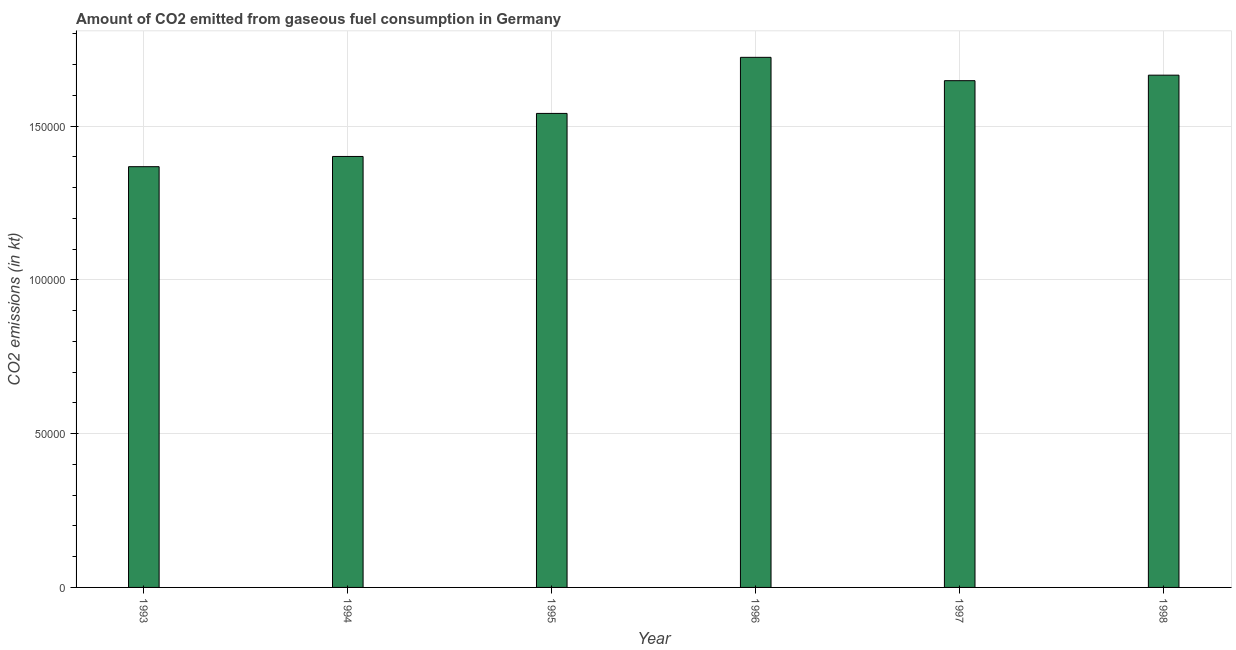What is the title of the graph?
Keep it short and to the point. Amount of CO2 emitted from gaseous fuel consumption in Germany. What is the label or title of the Y-axis?
Offer a very short reply. CO2 emissions (in kt). What is the co2 emissions from gaseous fuel consumption in 1997?
Ensure brevity in your answer.  1.65e+05. Across all years, what is the maximum co2 emissions from gaseous fuel consumption?
Keep it short and to the point. 1.72e+05. Across all years, what is the minimum co2 emissions from gaseous fuel consumption?
Keep it short and to the point. 1.37e+05. In which year was the co2 emissions from gaseous fuel consumption maximum?
Ensure brevity in your answer.  1996. In which year was the co2 emissions from gaseous fuel consumption minimum?
Your answer should be compact. 1993. What is the sum of the co2 emissions from gaseous fuel consumption?
Offer a terse response. 9.35e+05. What is the difference between the co2 emissions from gaseous fuel consumption in 1994 and 1996?
Offer a very short reply. -3.22e+04. What is the average co2 emissions from gaseous fuel consumption per year?
Offer a very short reply. 1.56e+05. What is the median co2 emissions from gaseous fuel consumption?
Offer a terse response. 1.59e+05. In how many years, is the co2 emissions from gaseous fuel consumption greater than 20000 kt?
Your answer should be very brief. 6. Do a majority of the years between 1998 and 1994 (inclusive) have co2 emissions from gaseous fuel consumption greater than 140000 kt?
Your answer should be compact. Yes. What is the ratio of the co2 emissions from gaseous fuel consumption in 1994 to that in 1996?
Make the answer very short. 0.81. What is the difference between the highest and the second highest co2 emissions from gaseous fuel consumption?
Provide a short and direct response. 5801.19. Is the sum of the co2 emissions from gaseous fuel consumption in 1994 and 1995 greater than the maximum co2 emissions from gaseous fuel consumption across all years?
Offer a terse response. Yes. What is the difference between the highest and the lowest co2 emissions from gaseous fuel consumption?
Your answer should be very brief. 3.56e+04. In how many years, is the co2 emissions from gaseous fuel consumption greater than the average co2 emissions from gaseous fuel consumption taken over all years?
Give a very brief answer. 3. How many bars are there?
Provide a succinct answer. 6. Are all the bars in the graph horizontal?
Your answer should be very brief. No. How many years are there in the graph?
Make the answer very short. 6. What is the CO2 emissions (in kt) of 1993?
Your answer should be very brief. 1.37e+05. What is the CO2 emissions (in kt) in 1994?
Offer a very short reply. 1.40e+05. What is the CO2 emissions (in kt) in 1995?
Give a very brief answer. 1.54e+05. What is the CO2 emissions (in kt) in 1996?
Provide a succinct answer. 1.72e+05. What is the CO2 emissions (in kt) in 1997?
Your answer should be compact. 1.65e+05. What is the CO2 emissions (in kt) in 1998?
Ensure brevity in your answer.  1.67e+05. What is the difference between the CO2 emissions (in kt) in 1993 and 1994?
Your answer should be very brief. -3325.97. What is the difference between the CO2 emissions (in kt) in 1993 and 1995?
Provide a short and direct response. -1.73e+04. What is the difference between the CO2 emissions (in kt) in 1993 and 1996?
Your answer should be compact. -3.56e+04. What is the difference between the CO2 emissions (in kt) in 1993 and 1997?
Provide a succinct answer. -2.80e+04. What is the difference between the CO2 emissions (in kt) in 1993 and 1998?
Offer a terse response. -2.98e+04. What is the difference between the CO2 emissions (in kt) in 1994 and 1995?
Your response must be concise. -1.40e+04. What is the difference between the CO2 emissions (in kt) in 1994 and 1996?
Provide a succinct answer. -3.22e+04. What is the difference between the CO2 emissions (in kt) in 1994 and 1997?
Make the answer very short. -2.46e+04. What is the difference between the CO2 emissions (in kt) in 1994 and 1998?
Your answer should be compact. -2.64e+04. What is the difference between the CO2 emissions (in kt) in 1995 and 1996?
Ensure brevity in your answer.  -1.82e+04. What is the difference between the CO2 emissions (in kt) in 1995 and 1997?
Keep it short and to the point. -1.06e+04. What is the difference between the CO2 emissions (in kt) in 1995 and 1998?
Your answer should be compact. -1.24e+04. What is the difference between the CO2 emissions (in kt) in 1996 and 1997?
Offer a terse response. 7590.69. What is the difference between the CO2 emissions (in kt) in 1996 and 1998?
Provide a short and direct response. 5801.19. What is the difference between the CO2 emissions (in kt) in 1997 and 1998?
Provide a short and direct response. -1789.5. What is the ratio of the CO2 emissions (in kt) in 1993 to that in 1994?
Give a very brief answer. 0.98. What is the ratio of the CO2 emissions (in kt) in 1993 to that in 1995?
Provide a short and direct response. 0.89. What is the ratio of the CO2 emissions (in kt) in 1993 to that in 1996?
Keep it short and to the point. 0.79. What is the ratio of the CO2 emissions (in kt) in 1993 to that in 1997?
Your answer should be compact. 0.83. What is the ratio of the CO2 emissions (in kt) in 1993 to that in 1998?
Give a very brief answer. 0.82. What is the ratio of the CO2 emissions (in kt) in 1994 to that in 1995?
Provide a short and direct response. 0.91. What is the ratio of the CO2 emissions (in kt) in 1994 to that in 1996?
Keep it short and to the point. 0.81. What is the ratio of the CO2 emissions (in kt) in 1994 to that in 1998?
Keep it short and to the point. 0.84. What is the ratio of the CO2 emissions (in kt) in 1995 to that in 1996?
Give a very brief answer. 0.89. What is the ratio of the CO2 emissions (in kt) in 1995 to that in 1997?
Provide a succinct answer. 0.94. What is the ratio of the CO2 emissions (in kt) in 1995 to that in 1998?
Your answer should be compact. 0.93. What is the ratio of the CO2 emissions (in kt) in 1996 to that in 1997?
Your answer should be compact. 1.05. What is the ratio of the CO2 emissions (in kt) in 1996 to that in 1998?
Ensure brevity in your answer.  1.03. What is the ratio of the CO2 emissions (in kt) in 1997 to that in 1998?
Keep it short and to the point. 0.99. 